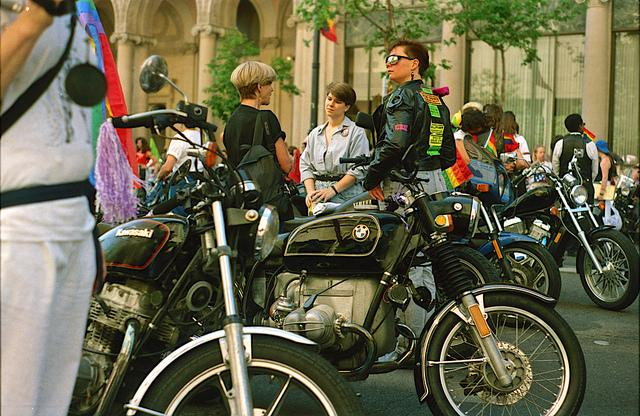What type of biking event is being held here?

Choices:
A) hetrosexual
B) sit in
C) bake sale
D) gay gay 